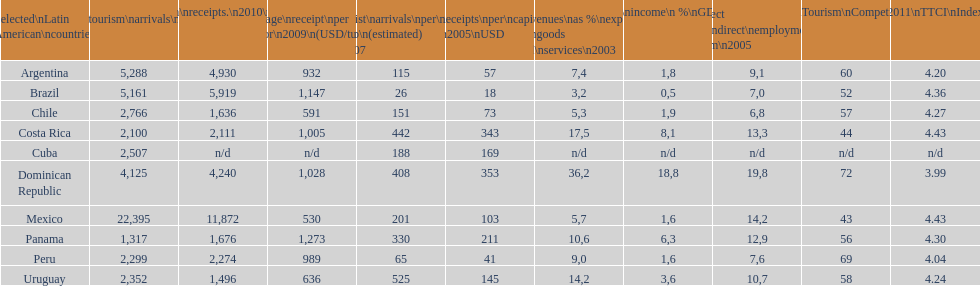What country makes the most tourist income? Dominican Republic. 